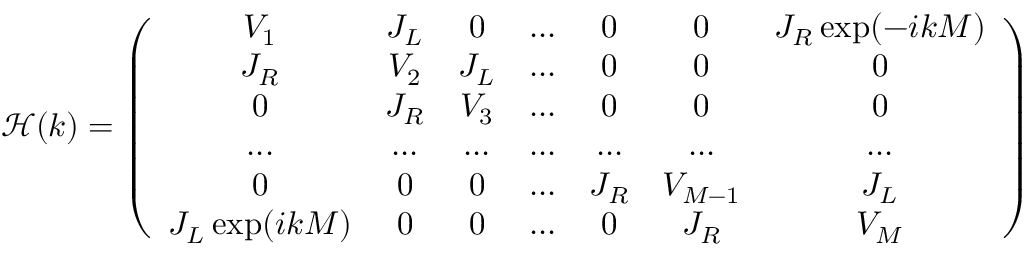Convert formula to latex. <formula><loc_0><loc_0><loc_500><loc_500>\mathcal { H } ( k ) = \left ( \begin{array} { c c c c c c c } { V _ { 1 } } & { J _ { L } } & { 0 } & { \dots } & { 0 } & { 0 } & { J _ { R } \exp ( - i k M ) } \\ { J _ { R } } & { V _ { 2 } } & { J _ { L } } & { \dots } & { 0 } & { 0 } & { 0 } \\ { 0 } & { J _ { R } } & { V _ { 3 } } & { \dots } & { 0 } & { 0 } & { 0 } \\ { \dots } & { \dots } & { \dots } & { \dots } & { \dots } & { \dots } & { \dots } \\ { 0 } & { 0 } & { 0 } & { \dots } & { J _ { R } } & { V _ { M - 1 } } & { J _ { L } } \\ { J _ { L } \exp ( i k M ) } & { 0 } & { 0 } & { \dots } & { 0 } & { J _ { R } } & { V _ { M } } \end{array} \right )</formula> 